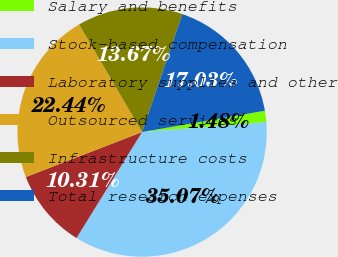Convert chart to OTSL. <chart><loc_0><loc_0><loc_500><loc_500><pie_chart><fcel>Salary and benefits<fcel>Stock-based compensation<fcel>Laboratory supplies and other<fcel>Outsourced services<fcel>Infrastructure costs<fcel>Total research expenses<nl><fcel>1.48%<fcel>35.07%<fcel>10.31%<fcel>22.44%<fcel>13.67%<fcel>17.03%<nl></chart> 